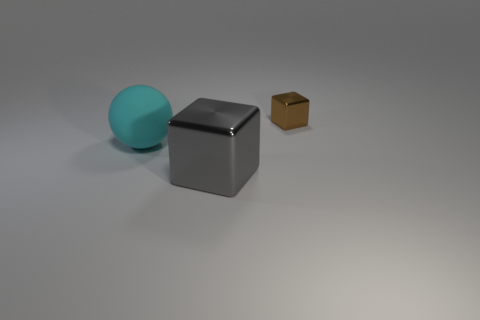Add 2 small brown objects. How many objects exist? 5 Subtract all cubes. How many objects are left? 1 Add 1 small blue rubber cubes. How many small blue rubber cubes exist? 1 Subtract 0 yellow spheres. How many objects are left? 3 Subtract 1 blocks. How many blocks are left? 1 Subtract all yellow cubes. Subtract all green spheres. How many cubes are left? 2 Subtract all brown blocks. How many red spheres are left? 0 Subtract all small gray shiny objects. Subtract all spheres. How many objects are left? 2 Add 3 brown shiny things. How many brown shiny things are left? 4 